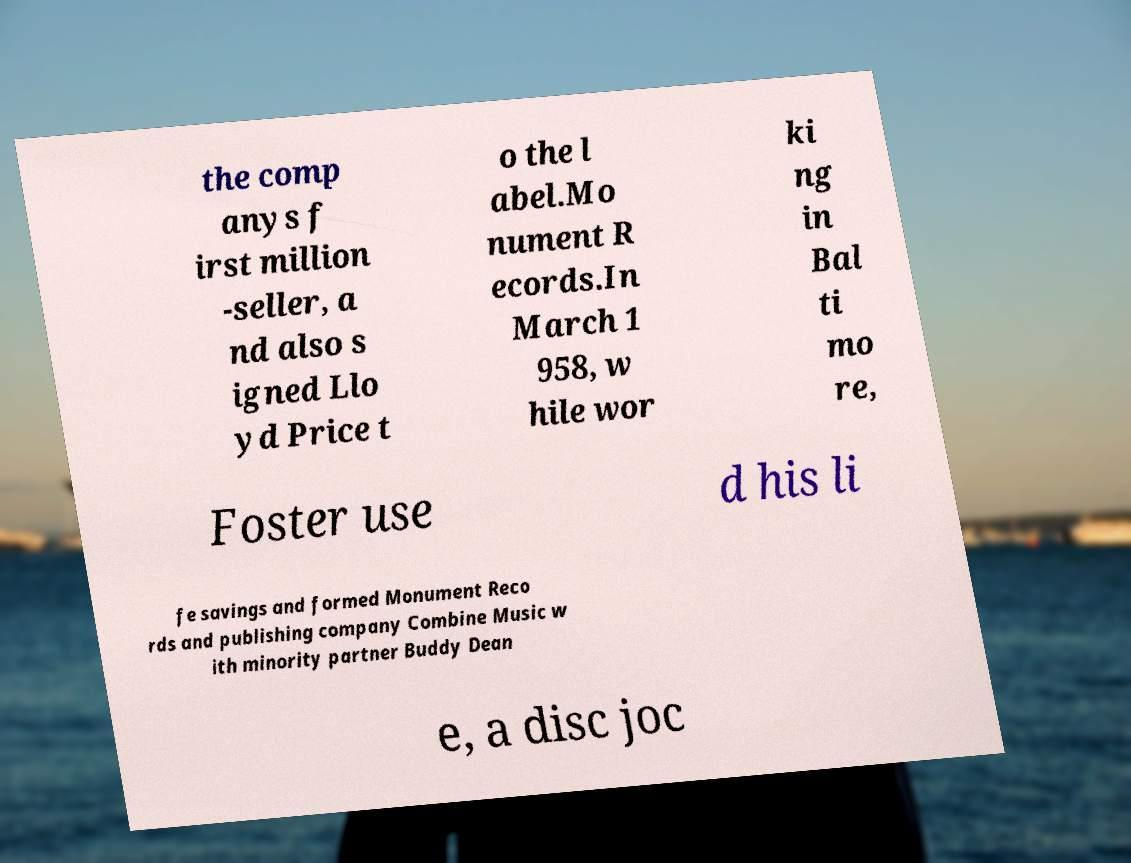For documentation purposes, I need the text within this image transcribed. Could you provide that? the comp anys f irst million -seller, a nd also s igned Llo yd Price t o the l abel.Mo nument R ecords.In March 1 958, w hile wor ki ng in Bal ti mo re, Foster use d his li fe savings and formed Monument Reco rds and publishing company Combine Music w ith minority partner Buddy Dean e, a disc joc 